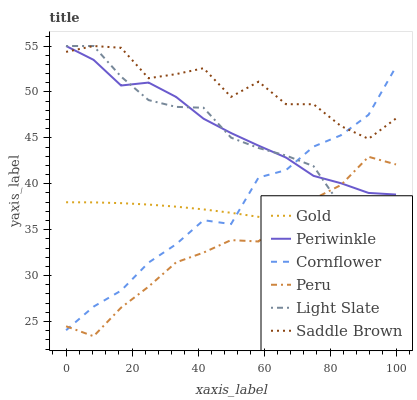Does Peru have the minimum area under the curve?
Answer yes or no. Yes. Does Saddle Brown have the maximum area under the curve?
Answer yes or no. Yes. Does Gold have the minimum area under the curve?
Answer yes or no. No. Does Gold have the maximum area under the curve?
Answer yes or no. No. Is Gold the smoothest?
Answer yes or no. Yes. Is Saddle Brown the roughest?
Answer yes or no. Yes. Is Light Slate the smoothest?
Answer yes or no. No. Is Light Slate the roughest?
Answer yes or no. No. Does Peru have the lowest value?
Answer yes or no. Yes. Does Gold have the lowest value?
Answer yes or no. No. Does Saddle Brown have the highest value?
Answer yes or no. Yes. Does Gold have the highest value?
Answer yes or no. No. Is Peru less than Saddle Brown?
Answer yes or no. Yes. Is Saddle Brown greater than Gold?
Answer yes or no. Yes. Does Periwinkle intersect Cornflower?
Answer yes or no. Yes. Is Periwinkle less than Cornflower?
Answer yes or no. No. Is Periwinkle greater than Cornflower?
Answer yes or no. No. Does Peru intersect Saddle Brown?
Answer yes or no. No. 